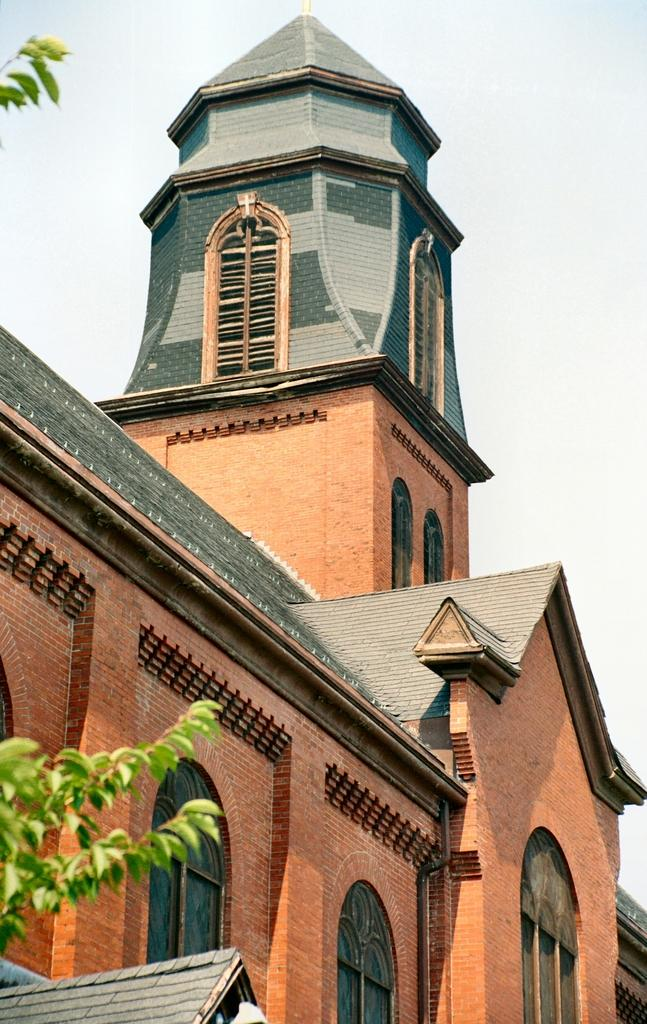What type of structure is present in the image? There is a building in the image. What colors are used to depict the building? The building is in brown and grey colors. What can be seen to the left of the building? There is a tree to the left of the building. What color is the tree? The tree is in green color. What is visible in the background of the image? The sky is visible in the background of the image. What color is the sky? The sky is white in color. What type of juice is being served in the image? There is no juice present in the image; it features a building, a tree, and the sky. How many books are visible on the tree in the image? There are no books present in the image, as it features a building, a tree, and the sky. 